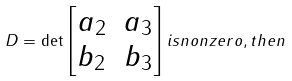Convert formula to latex. <formula><loc_0><loc_0><loc_500><loc_500>D = \det \left [ \begin{matrix} a _ { 2 } & a _ { 3 } \\ b _ { 2 } & b _ { 3 } \end{matrix} \right ] i s n o n z e r o , t h e n</formula> 